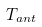<formula> <loc_0><loc_0><loc_500><loc_500>T _ { a n t }</formula> 